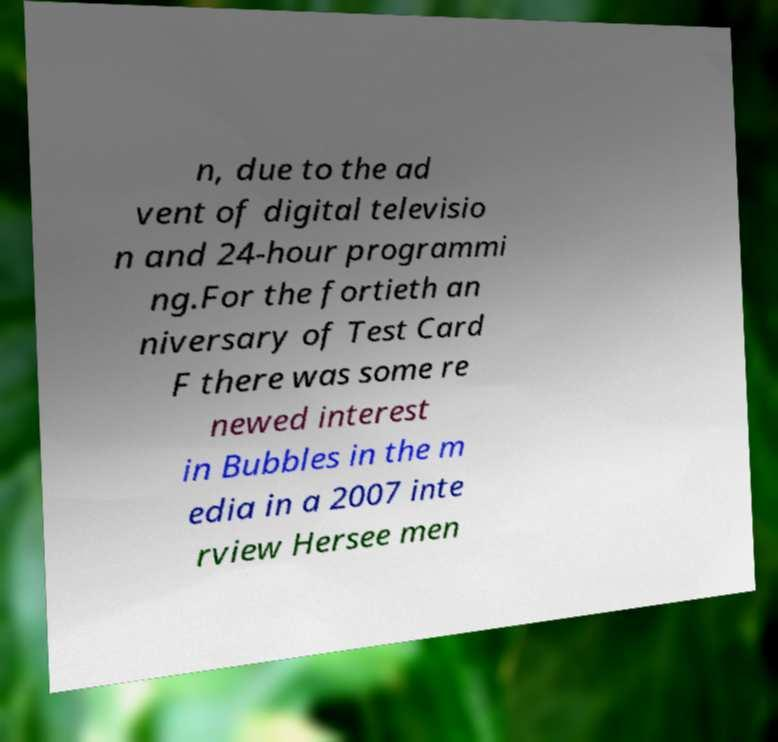Please identify and transcribe the text found in this image. n, due to the ad vent of digital televisio n and 24-hour programmi ng.For the fortieth an niversary of Test Card F there was some re newed interest in Bubbles in the m edia in a 2007 inte rview Hersee men 